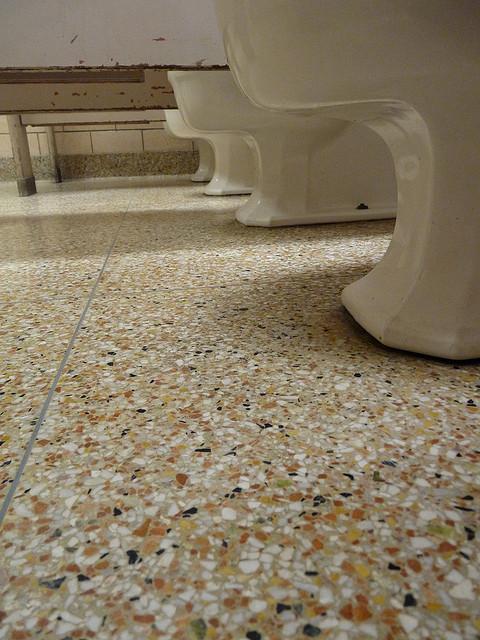Is the toilet seat ceramic?
Answer briefly. Yes. What room is this?
Answer briefly. Bathroom. How many toilets are visible?
Concise answer only. 4. Is the a private bathroom?
Keep it brief. No. 